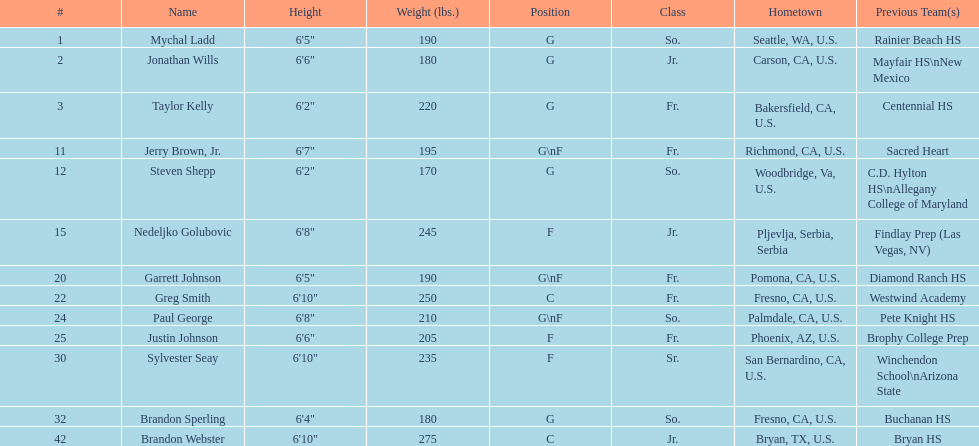Can you parse all the data within this table? {'header': ['#', 'Name', 'Height', 'Weight (lbs.)', 'Position', 'Class', 'Hometown', 'Previous Team(s)'], 'rows': [['1', 'Mychal Ladd', '6\'5"', '190', 'G', 'So.', 'Seattle, WA, U.S.', 'Rainier Beach HS'], ['2', 'Jonathan Wills', '6\'6"', '180', 'G', 'Jr.', 'Carson, CA, U.S.', 'Mayfair HS\\nNew Mexico'], ['3', 'Taylor Kelly', '6\'2"', '220', 'G', 'Fr.', 'Bakersfield, CA, U.S.', 'Centennial HS'], ['11', 'Jerry Brown, Jr.', '6\'7"', '195', 'G\\nF', 'Fr.', 'Richmond, CA, U.S.', 'Sacred Heart'], ['12', 'Steven Shepp', '6\'2"', '170', 'G', 'So.', 'Woodbridge, Va, U.S.', 'C.D. Hylton HS\\nAllegany College of Maryland'], ['15', 'Nedeljko Golubovic', '6\'8"', '245', 'F', 'Jr.', 'Pljevlja, Serbia, Serbia', 'Findlay Prep (Las Vegas, NV)'], ['20', 'Garrett Johnson', '6\'5"', '190', 'G\\nF', 'Fr.', 'Pomona, CA, U.S.', 'Diamond Ranch HS'], ['22', 'Greg Smith', '6\'10"', '250', 'C', 'Fr.', 'Fresno, CA, U.S.', 'Westwind Academy'], ['24', 'Paul George', '6\'8"', '210', 'G\\nF', 'So.', 'Palmdale, CA, U.S.', 'Pete Knight HS'], ['25', 'Justin Johnson', '6\'6"', '205', 'F', 'Fr.', 'Phoenix, AZ, U.S.', 'Brophy College Prep'], ['30', 'Sylvester Seay', '6\'10"', '235', 'F', 'Sr.', 'San Bernardino, CA, U.S.', 'Winchendon School\\nArizona State'], ['32', 'Brandon Sperling', '6\'4"', '180', 'G', 'So.', 'Fresno, CA, U.S.', 'Buchanan HS'], ['42', 'Brandon Webster', '6\'10"', '275', 'C', 'Jr.', 'Bryan, TX, U.S.', 'Bryan HS']]} Which player, being solely a forward (f), possesses the smallest stature? Justin Johnson. 